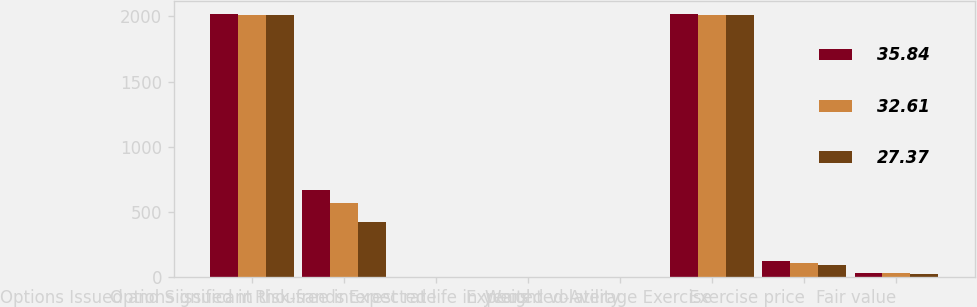Convert chart to OTSL. <chart><loc_0><loc_0><loc_500><loc_500><stacked_bar_chart><ecel><fcel>Options Issued and Significant<fcel>Options issued in thousands<fcel>Risk-free interest rate<fcel>Expected life in years<fcel>Expected volatility<fcel>Weighted-Average Exercise<fcel>Exercise price<fcel>Fair value<nl><fcel>35.84<fcel>2015<fcel>673<fcel>1.8<fcel>6<fcel>0.26<fcel>2015<fcel>127.63<fcel>35.84<nl><fcel>32.61<fcel>2014<fcel>569<fcel>1.6<fcel>6<fcel>0.27<fcel>2014<fcel>112.56<fcel>32.61<nl><fcel>27.37<fcel>2013<fcel>428<fcel>1.7<fcel>5<fcel>0.25<fcel>2013<fcel>97.74<fcel>27.37<nl></chart> 